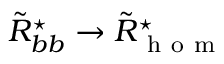<formula> <loc_0><loc_0><loc_500><loc_500>\tilde { R } _ { b b } ^ { ^ { * } } \rightarrow \tilde { R } _ { h o m } ^ { ^ { * } }</formula> 